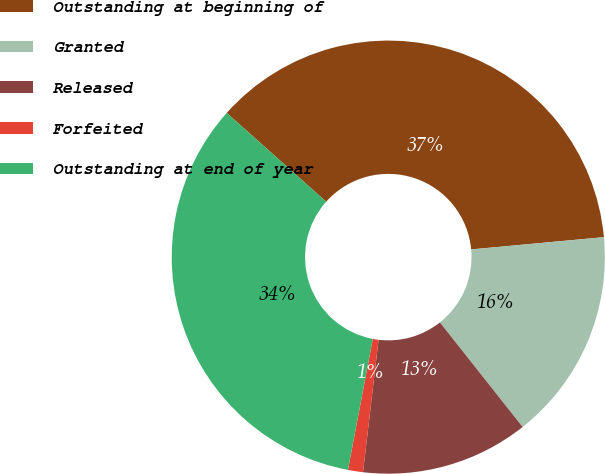Convert chart to OTSL. <chart><loc_0><loc_0><loc_500><loc_500><pie_chart><fcel>Outstanding at beginning of<fcel>Granted<fcel>Released<fcel>Forfeited<fcel>Outstanding at end of year<nl><fcel>36.93%<fcel>15.82%<fcel>12.51%<fcel>1.12%<fcel>33.61%<nl></chart> 